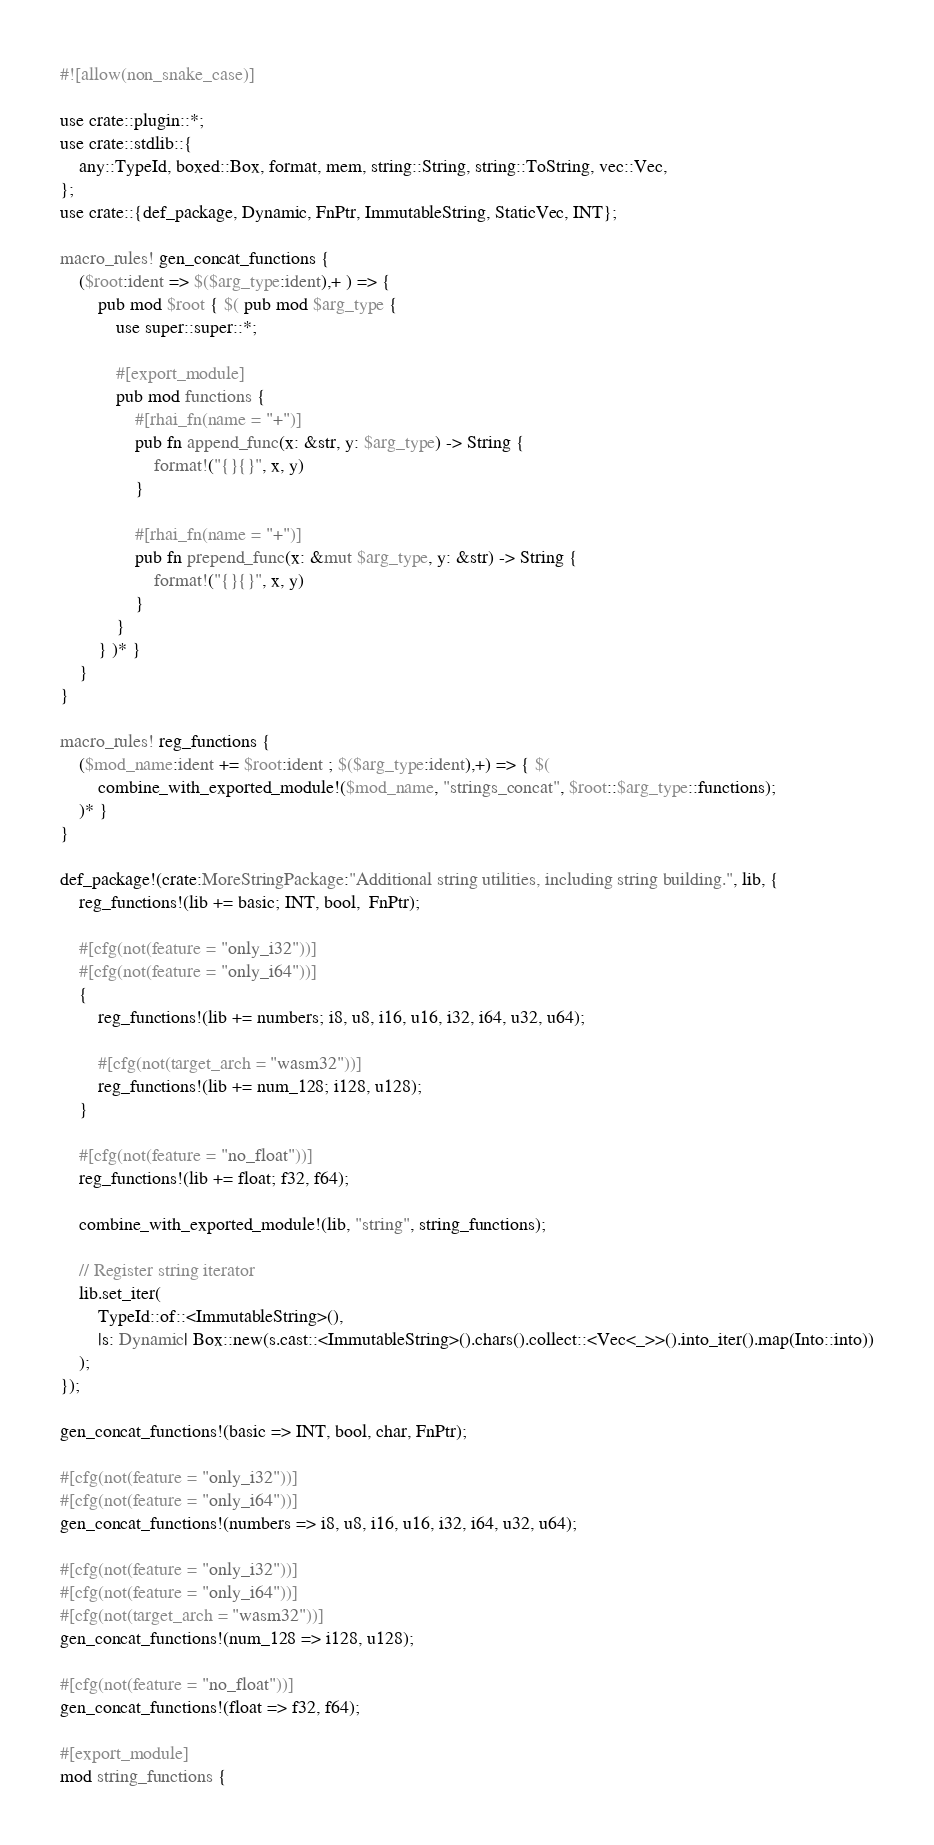Convert code to text. <code><loc_0><loc_0><loc_500><loc_500><_Rust_>#![allow(non_snake_case)]

use crate::plugin::*;
use crate::stdlib::{
    any::TypeId, boxed::Box, format, mem, string::String, string::ToString, vec::Vec,
};
use crate::{def_package, Dynamic, FnPtr, ImmutableString, StaticVec, INT};

macro_rules! gen_concat_functions {
    ($root:ident => $($arg_type:ident),+ ) => {
        pub mod $root { $( pub mod $arg_type {
            use super::super::*;

            #[export_module]
            pub mod functions {
                #[rhai_fn(name = "+")]
                pub fn append_func(x: &str, y: $arg_type) -> String {
                    format!("{}{}", x, y)
                }

                #[rhai_fn(name = "+")]
                pub fn prepend_func(x: &mut $arg_type, y: &str) -> String {
                    format!("{}{}", x, y)
                }
            }
        } )* }
    }
}

macro_rules! reg_functions {
    ($mod_name:ident += $root:ident ; $($arg_type:ident),+) => { $(
        combine_with_exported_module!($mod_name, "strings_concat", $root::$arg_type::functions);
    )* }
}

def_package!(crate:MoreStringPackage:"Additional string utilities, including string building.", lib, {
    reg_functions!(lib += basic; INT, bool,  FnPtr);

    #[cfg(not(feature = "only_i32"))]
    #[cfg(not(feature = "only_i64"))]
    {
        reg_functions!(lib += numbers; i8, u8, i16, u16, i32, i64, u32, u64);

        #[cfg(not(target_arch = "wasm32"))]
        reg_functions!(lib += num_128; i128, u128);
    }

    #[cfg(not(feature = "no_float"))]
    reg_functions!(lib += float; f32, f64);

    combine_with_exported_module!(lib, "string", string_functions);

    // Register string iterator
    lib.set_iter(
        TypeId::of::<ImmutableString>(),
        |s: Dynamic| Box::new(s.cast::<ImmutableString>().chars().collect::<Vec<_>>().into_iter().map(Into::into))
    );
});

gen_concat_functions!(basic => INT, bool, char, FnPtr);

#[cfg(not(feature = "only_i32"))]
#[cfg(not(feature = "only_i64"))]
gen_concat_functions!(numbers => i8, u8, i16, u16, i32, i64, u32, u64);

#[cfg(not(feature = "only_i32"))]
#[cfg(not(feature = "only_i64"))]
#[cfg(not(target_arch = "wasm32"))]
gen_concat_functions!(num_128 => i128, u128);

#[cfg(not(feature = "no_float"))]
gen_concat_functions!(float => f32, f64);

#[export_module]
mod string_functions {</code> 